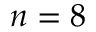Convert formula to latex. <formula><loc_0><loc_0><loc_500><loc_500>n = 8</formula> 